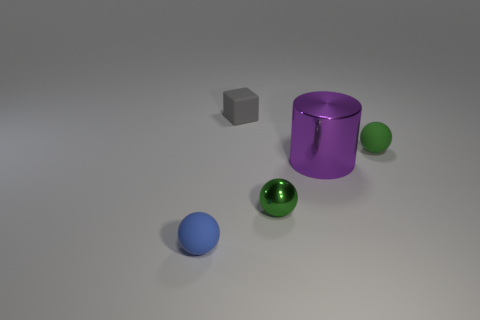What is the color of the tiny matte object in front of the small green sphere right of the purple metal cylinder?
Give a very brief answer. Blue. Is there a small cube that has the same material as the tiny blue sphere?
Your answer should be compact. Yes. There is a tiny green object behind the small green thing left of the big metallic thing; what is its material?
Ensure brevity in your answer.  Rubber. How many tiny rubber things have the same shape as the tiny green shiny object?
Make the answer very short. 2. There is a green rubber thing; what shape is it?
Make the answer very short. Sphere. Are there fewer red rubber things than large metal cylinders?
Your answer should be compact. Yes. Are there any other things that have the same size as the purple cylinder?
Your answer should be compact. No. What material is the other small green object that is the same shape as the green metal thing?
Offer a very short reply. Rubber. Are there more small objects than small yellow shiny cylinders?
Give a very brief answer. Yes. What number of other things are the same color as the small shiny object?
Your response must be concise. 1. 